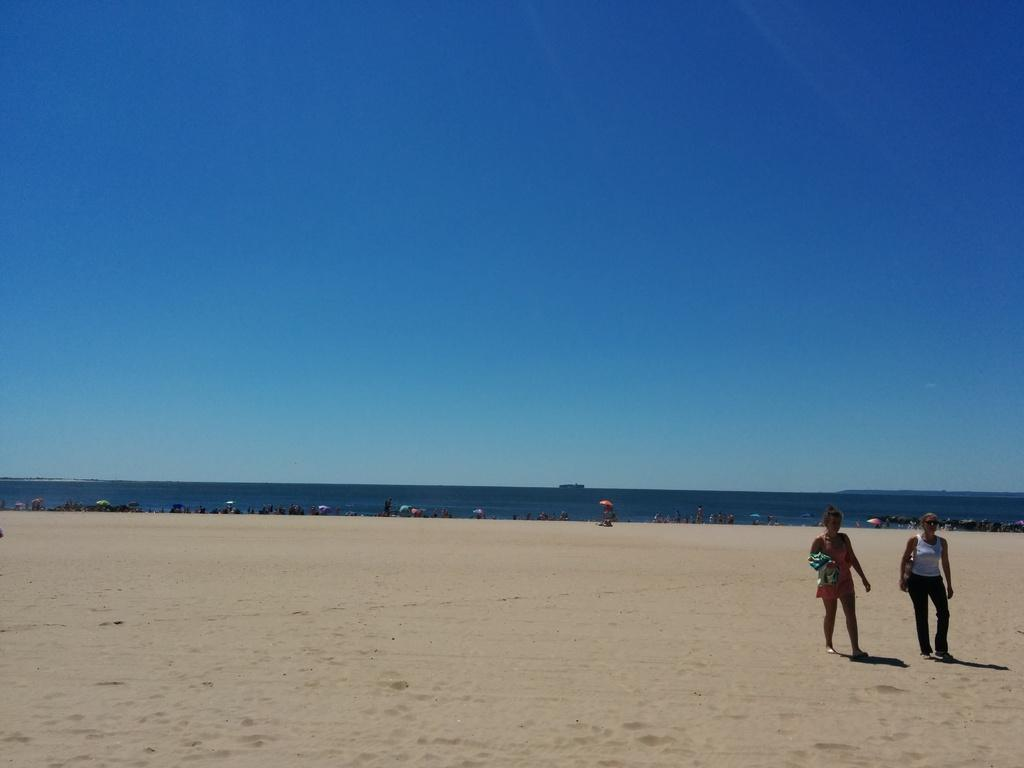What are the two women in the image doing? The two women are walking on the sand surface of the ground. What can be seen in the background of the image? In the background, there are persons near an ocean. What is the color of the sky in the image? There is a blue sky visible in the image. What type of pump can be seen near the women in the image? There is no pump present in the image; the women are walking on sand near an ocean. Are there any chairs visible in the image? There are no chairs visible in the image; the focus is on the women walking on the sand and the persons near the ocean in the background. 